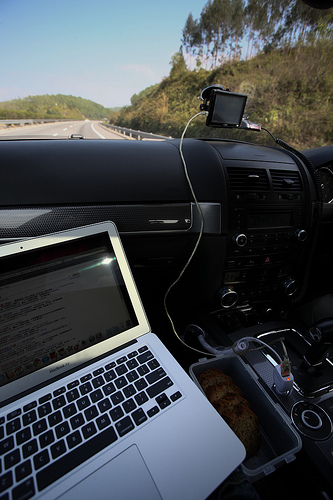<image>
Can you confirm if the charger is under the gear box? No. The charger is not positioned under the gear box. The vertical relationship between these objects is different. 